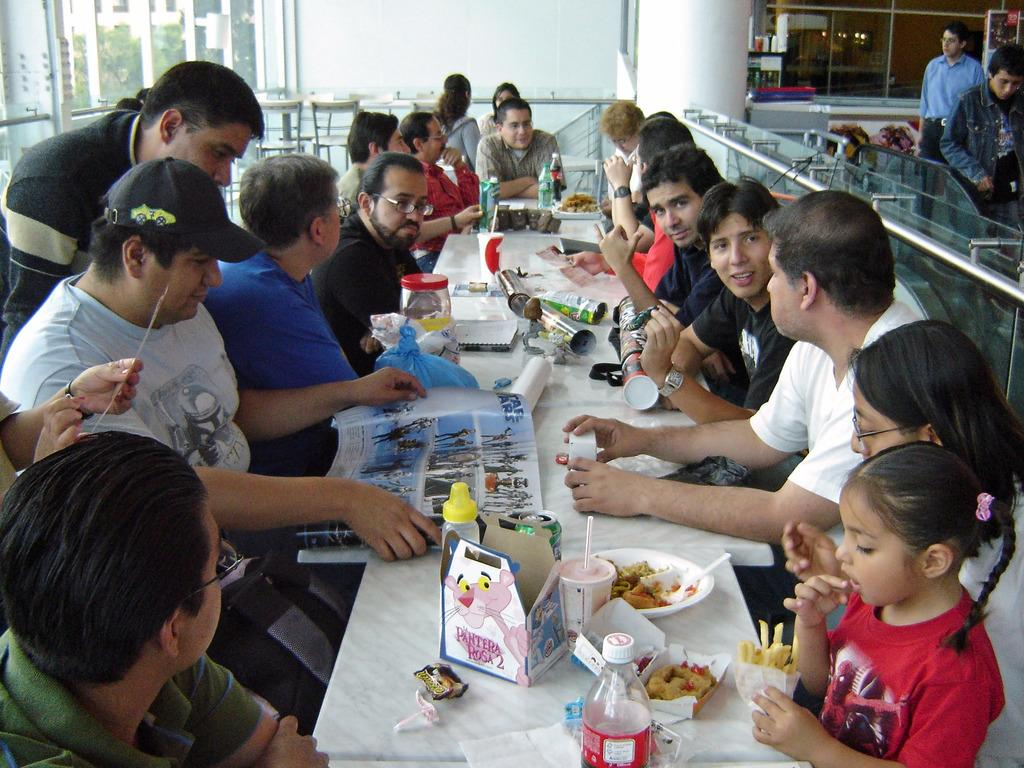How many people are in the image? There is a group of people in the image. What are the people doing in the image? The people are sitting on chairs. What can be seen besides the people in the image? There is a bottle, food on a plate, a box, and a man holding a sheet in the image. What type of skin is visible on the elbow of the person in the image? There is no visible skin or elbow in the image; the people are sitting on chairs and holding a sheet. 